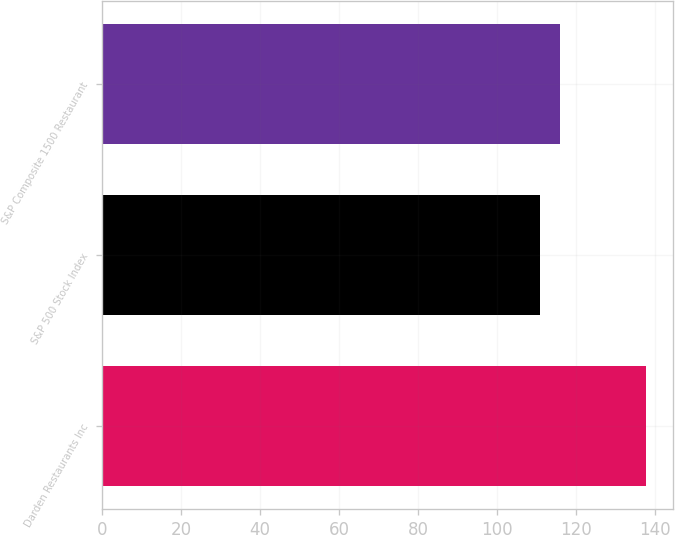Convert chart. <chart><loc_0><loc_0><loc_500><loc_500><bar_chart><fcel>Darden Restaurants Inc<fcel>S&P 500 Stock Index<fcel>S&P Composite 1500 Restaurant<nl><fcel>137.7<fcel>110.88<fcel>115.96<nl></chart> 